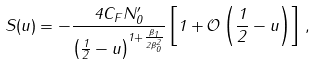Convert formula to latex. <formula><loc_0><loc_0><loc_500><loc_500>S ( u ) = - \frac { 4 C _ { F } N _ { 0 } ^ { \prime } } { \left ( \frac { 1 } { 2 } - u \right ) ^ { 1 + \frac { \beta _ { 1 } } { 2 \beta _ { 0 } ^ { 2 } } } } \left [ 1 + \mathcal { O } \left ( \frac { 1 } { 2 } - u \right ) \right ] \, ,</formula> 